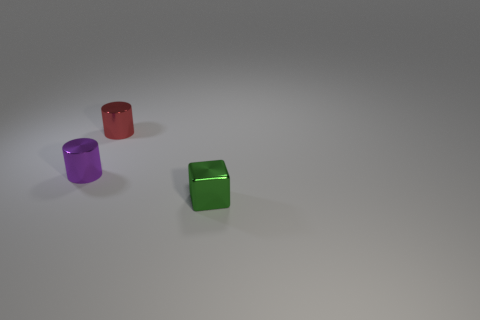There is a tiny cylinder that is in front of the small metallic object that is behind the tiny purple metallic cylinder; are there any metal cylinders to the left of it?
Provide a succinct answer. No. The tiny cube is what color?
Your answer should be compact. Green. What is the color of the block that is the same size as the red metallic cylinder?
Provide a succinct answer. Green. Is the shape of the tiny thing on the left side of the small red cylinder the same as  the small green metal thing?
Your answer should be very brief. No. There is a object right of the metallic cylinder to the right of the small metal cylinder in front of the red shiny cylinder; what color is it?
Your response must be concise. Green. Are there any red cylinders?
Keep it short and to the point. Yes. How many other things are the same size as the green cube?
Your answer should be very brief. 2. Is the color of the cube the same as the tiny metal cylinder that is in front of the tiny red cylinder?
Your answer should be compact. No. What number of things are tiny purple matte cylinders or purple shiny objects?
Offer a very short reply. 1. Is there anything else that has the same color as the small metallic block?
Give a very brief answer. No. 